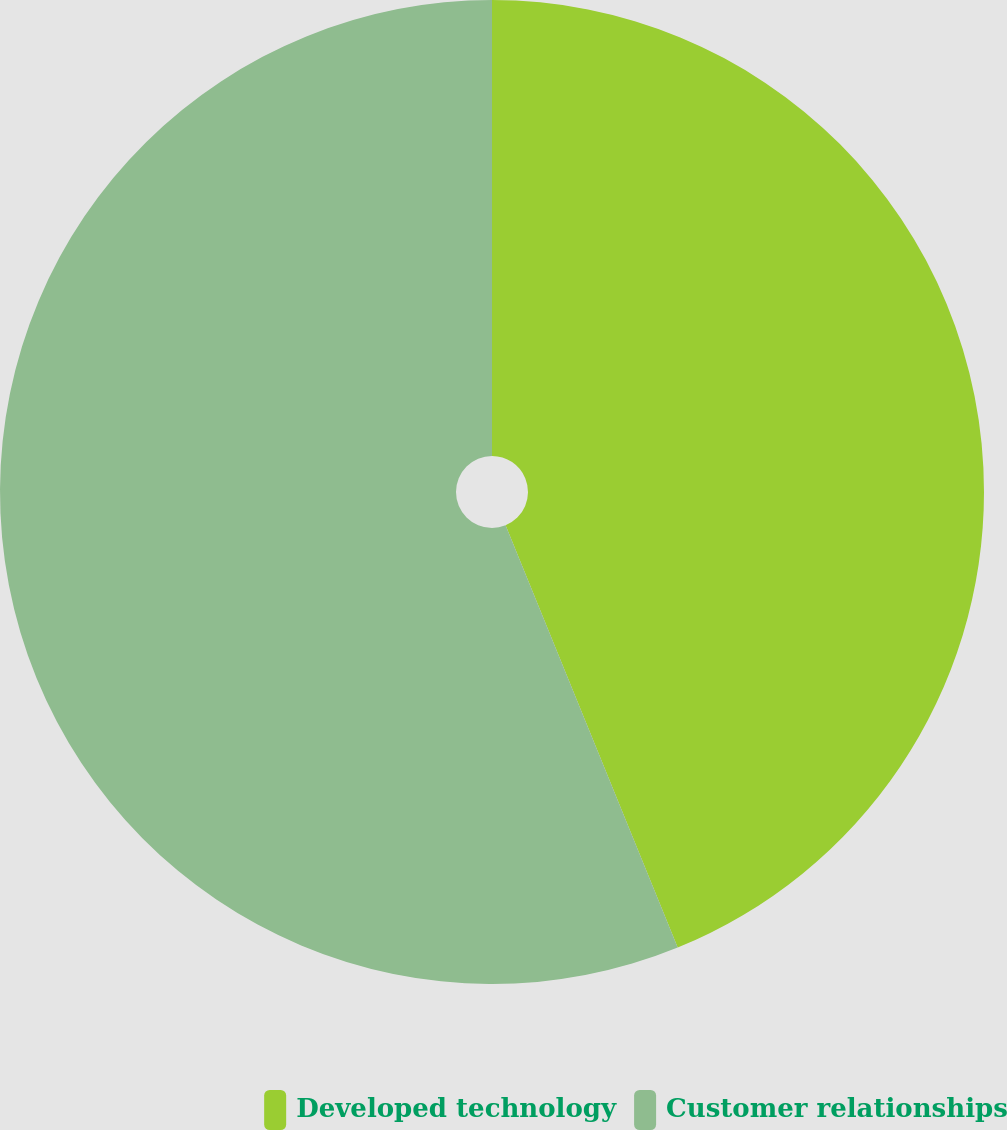Convert chart to OTSL. <chart><loc_0><loc_0><loc_500><loc_500><pie_chart><fcel>Developed technology<fcel>Customer relationships<nl><fcel>43.84%<fcel>56.16%<nl></chart> 